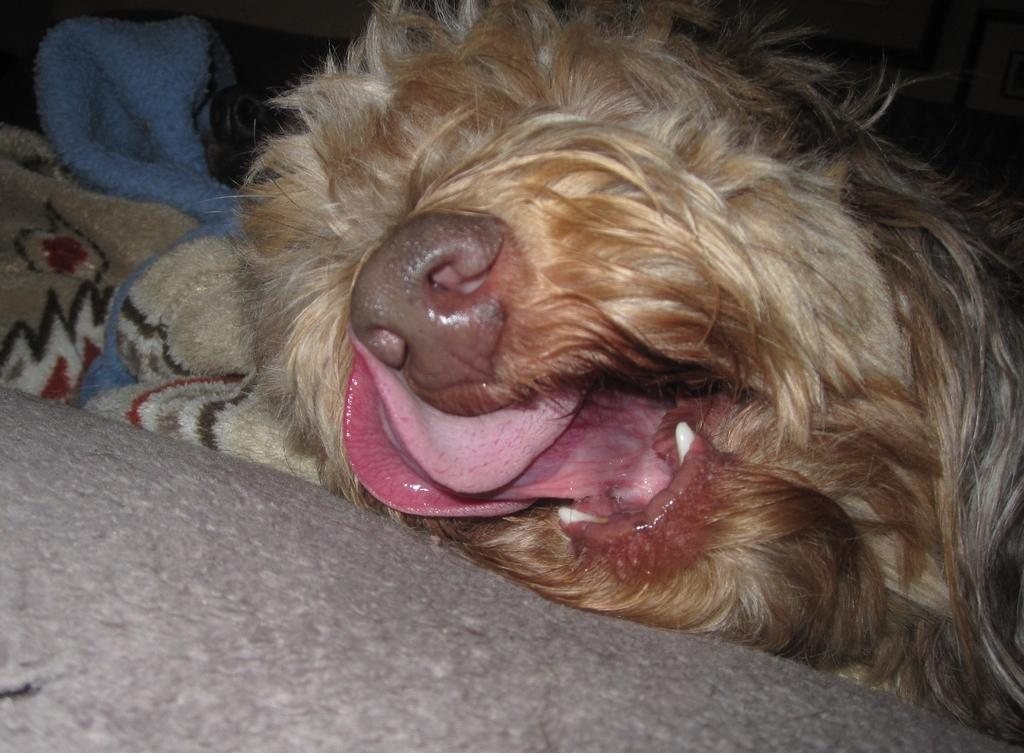What type of animal is present in the image? There is a dog in the image. What else can be seen on the left side of the image? There are clothes on the left side of the image. What type of wood is the dog using to build a relationship in the image? There is no wood present in the image, and the dog is not building any relationships. 